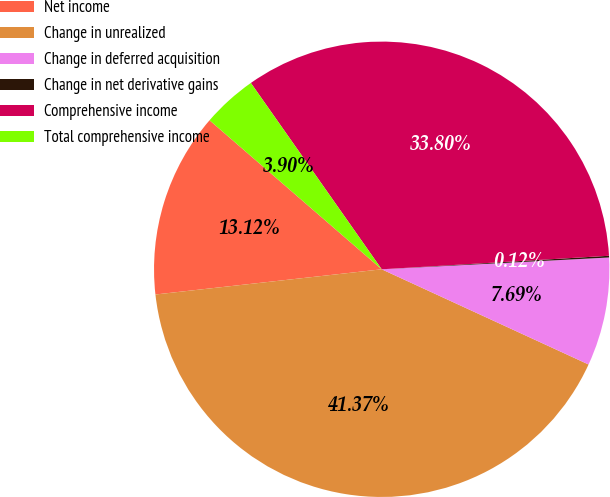Convert chart. <chart><loc_0><loc_0><loc_500><loc_500><pie_chart><fcel>Net income<fcel>Change in unrealized<fcel>Change in deferred acquisition<fcel>Change in net derivative gains<fcel>Comprehensive income<fcel>Total comprehensive income<nl><fcel>13.12%<fcel>41.37%<fcel>7.69%<fcel>0.12%<fcel>33.8%<fcel>3.9%<nl></chart> 